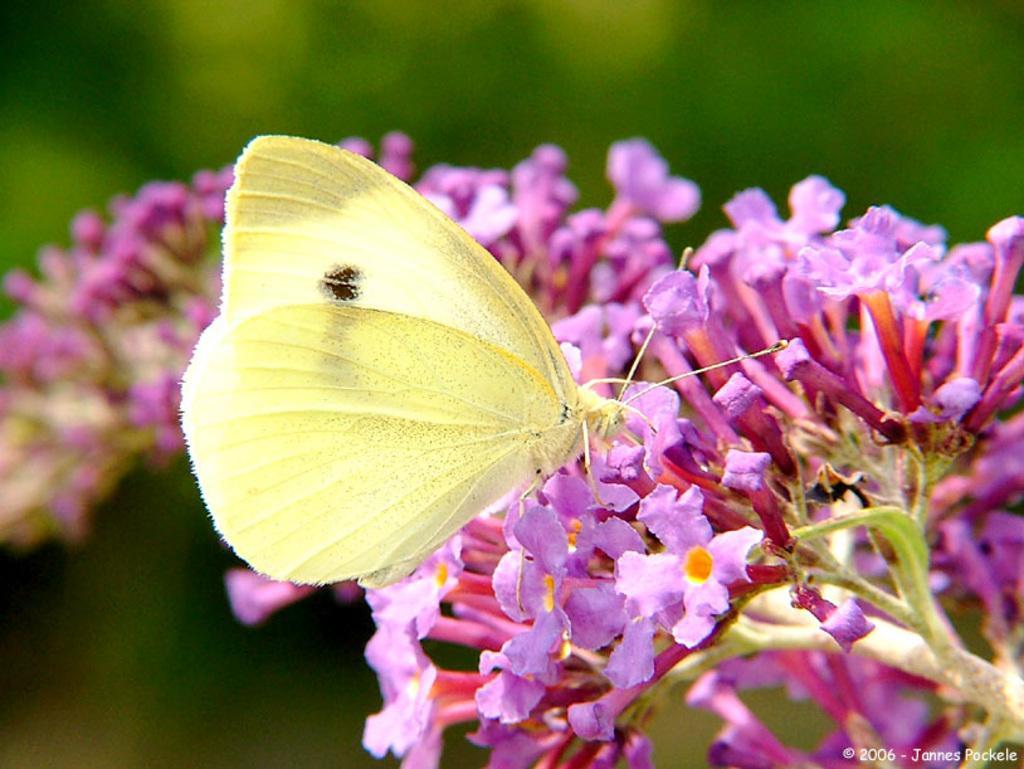Can you describe this image briefly? In the image there is a butterfly standing on purple flowers and the background is blurry. 